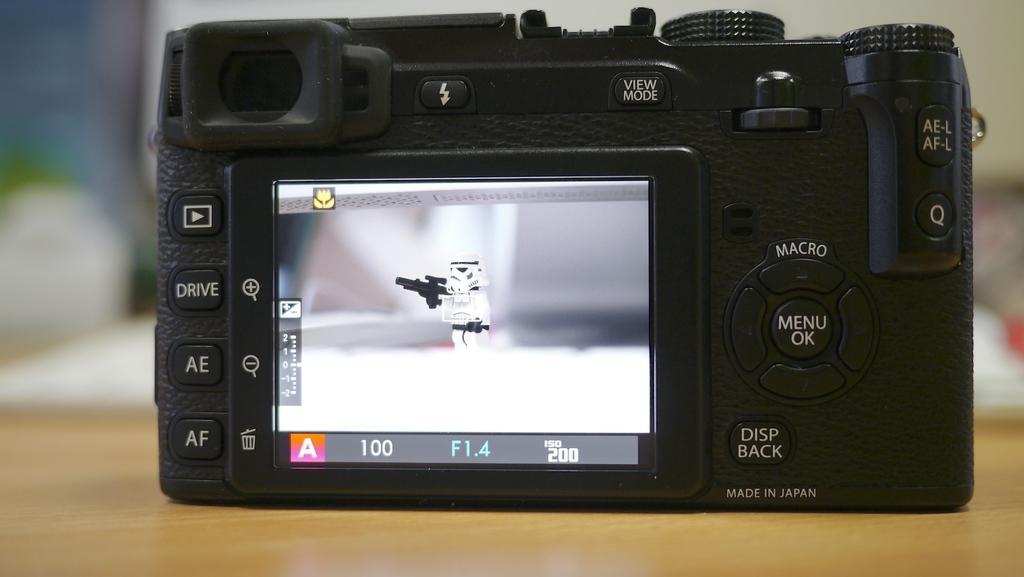Please provide a concise description of this image. In this picture there is a close view of the black color digital camera placed on a wooden table top. Behind there is a blur background. 